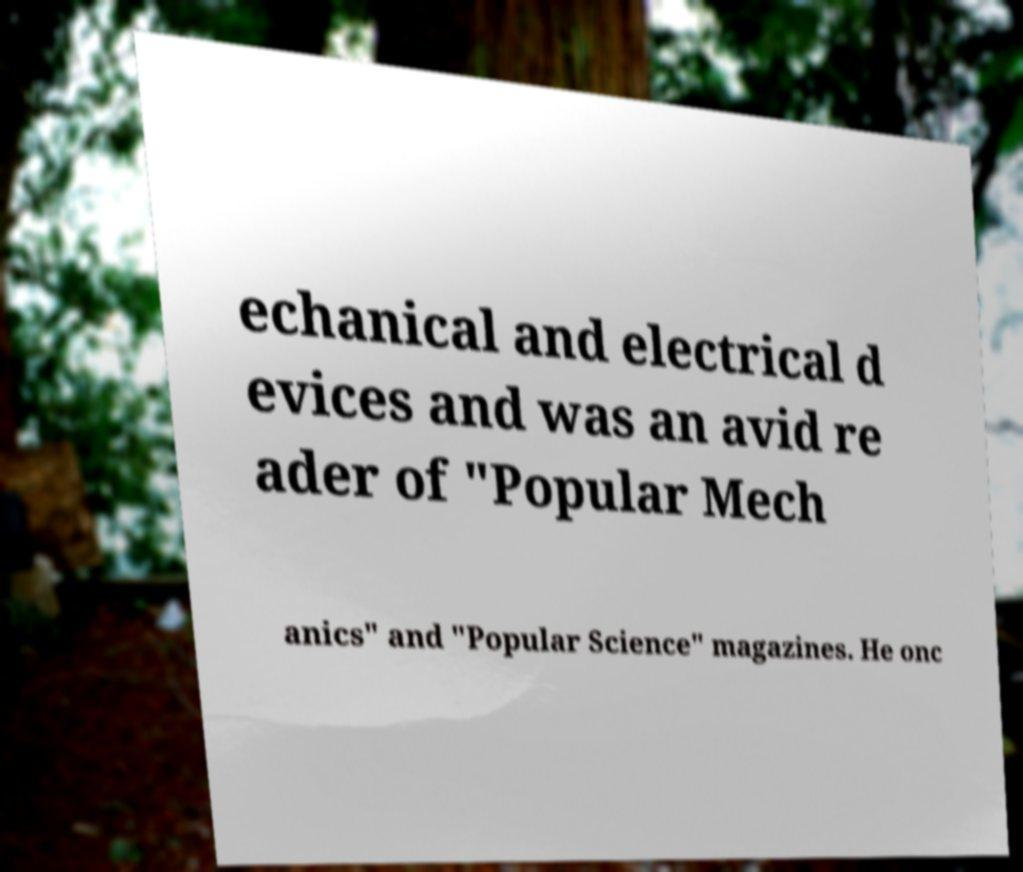Can you read and provide the text displayed in the image?This photo seems to have some interesting text. Can you extract and type it out for me? echanical and electrical d evices and was an avid re ader of "Popular Mech anics" and "Popular Science" magazines. He onc 